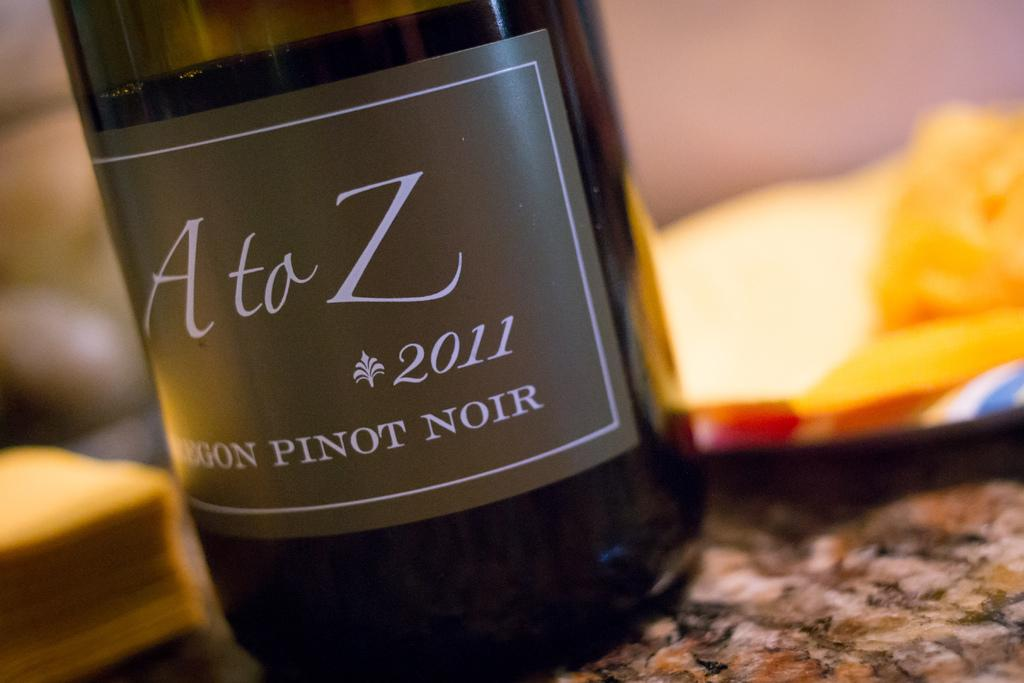Provide a one-sentence caption for the provided image. A bottle of A to Z pinot noir is from 2011. 